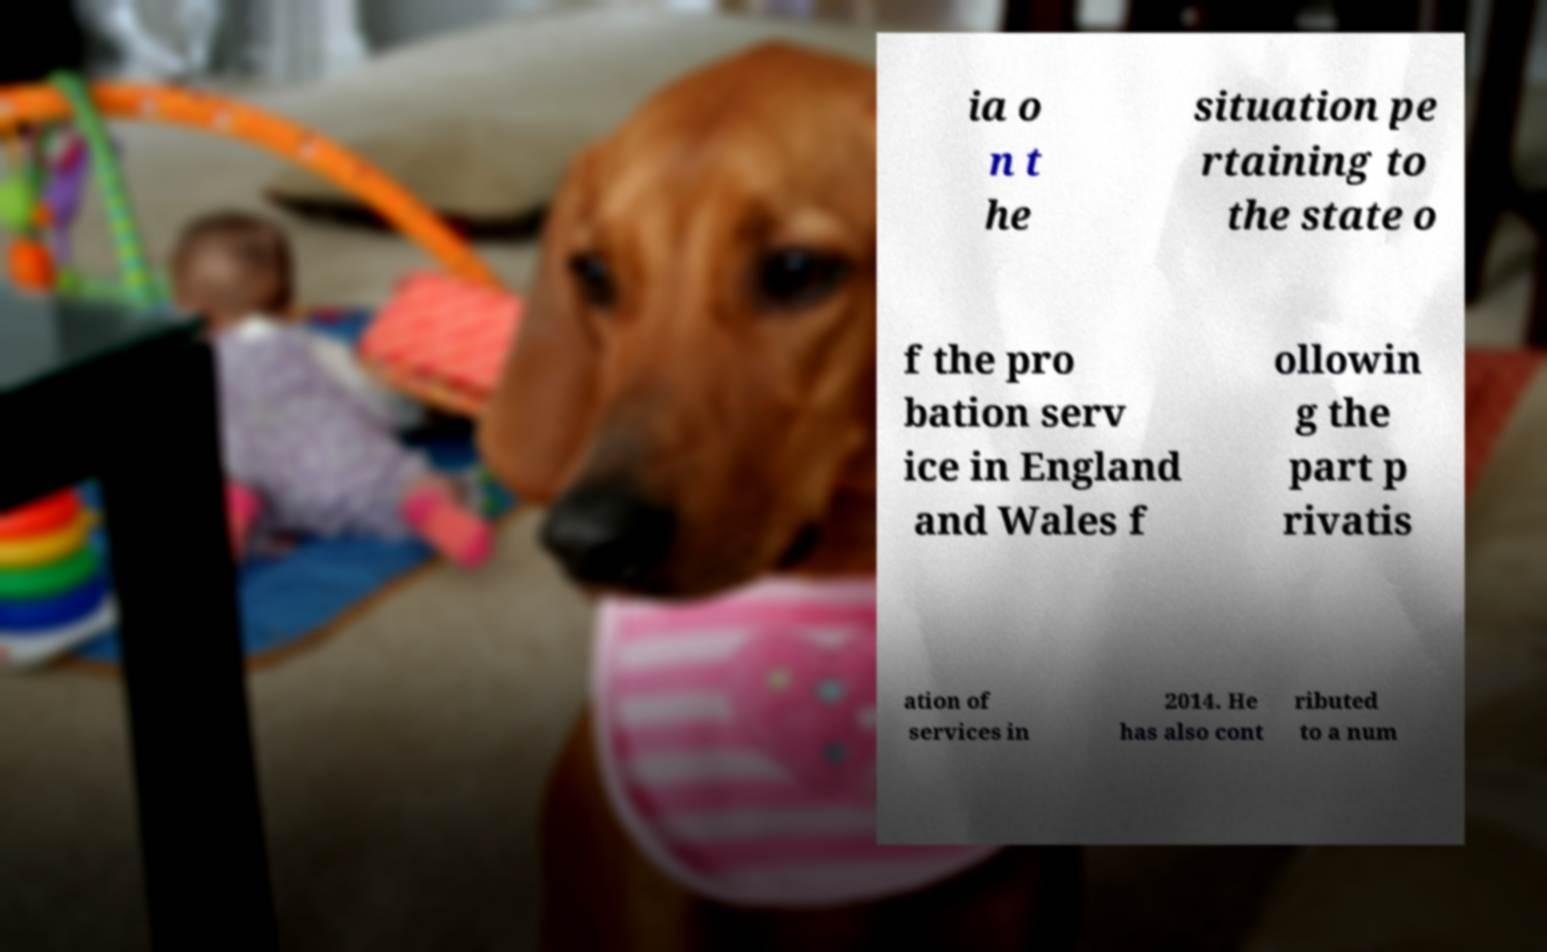Could you assist in decoding the text presented in this image and type it out clearly? ia o n t he situation pe rtaining to the state o f the pro bation serv ice in England and Wales f ollowin g the part p rivatis ation of services in 2014. He has also cont ributed to a num 